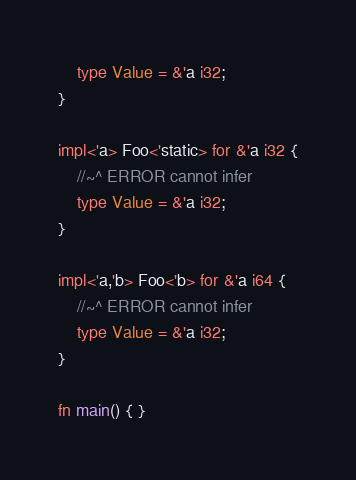Convert code to text. <code><loc_0><loc_0><loc_500><loc_500><_Rust_>    type Value = &'a i32;
}

impl<'a> Foo<'static> for &'a i32 {
    //~^ ERROR cannot infer
    type Value = &'a i32;
}

impl<'a,'b> Foo<'b> for &'a i64 {
    //~^ ERROR cannot infer
    type Value = &'a i32;
}

fn main() { }
</code> 